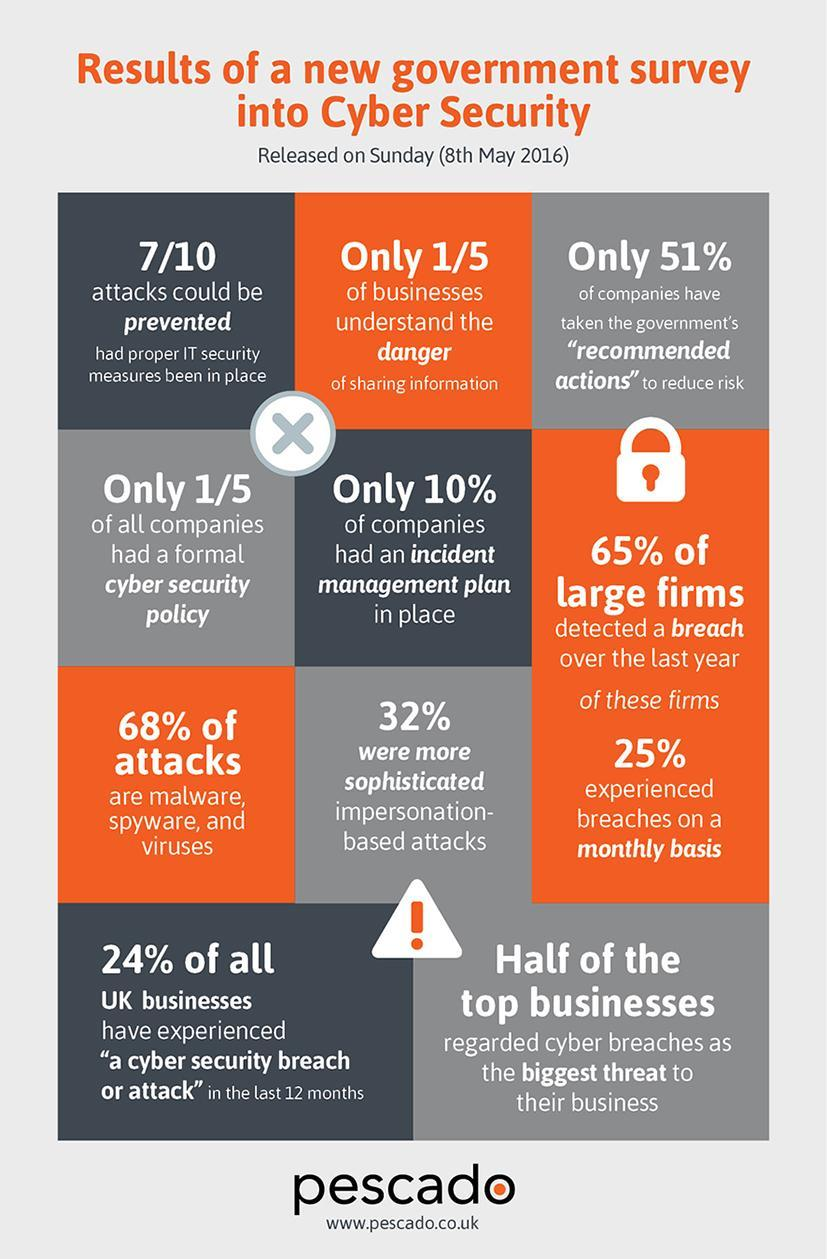What percent of cyber attacks in UK are malware, spyware & viruses as of 8th May 2016?
Answer the question with a short phrase. 68% What percentage of UK businesses didn't experience a cyber security breach or attack in the last 12 months? 76% What percentage of large firms in UK experienced breaches on a monthly basis as of 8th May 2016? 25% What percentage of companies in UK don't have an incident management plan as of 8th May 2016? 90% 